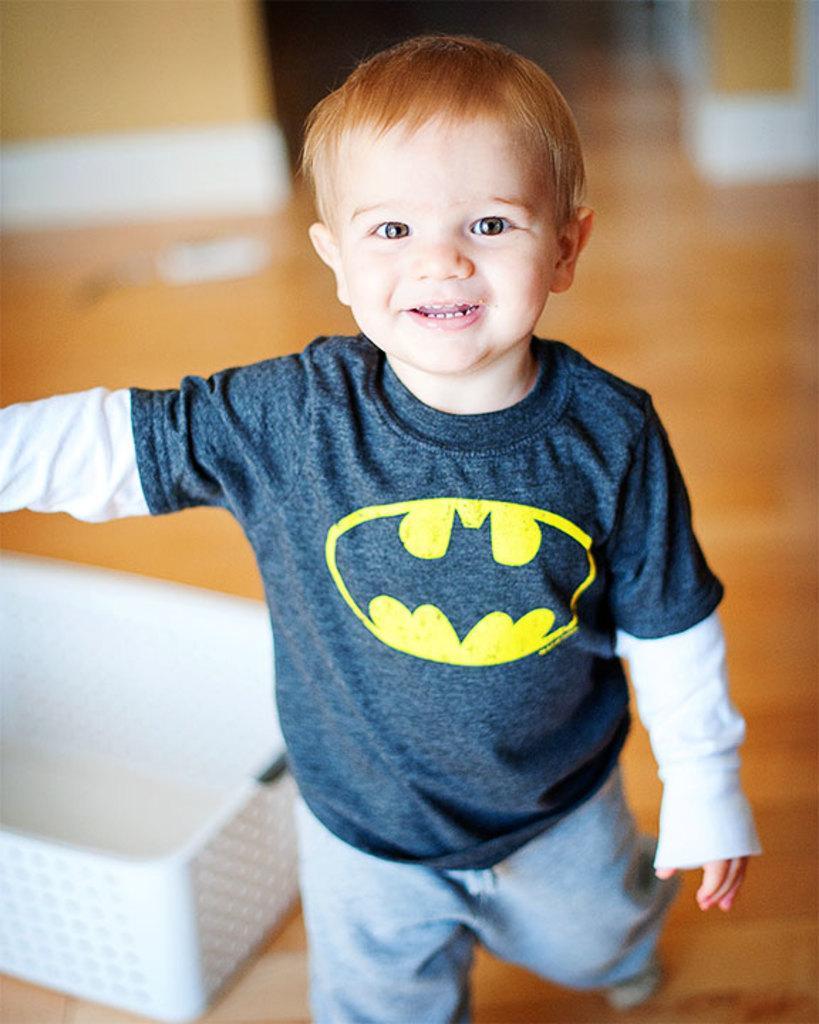In one or two sentences, can you explain what this image depicts? In this picture I can see a boy is standing on the floor. The boy is wearing a t shirt and pant. Here I can see white color basket. 